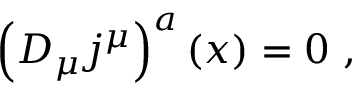Convert formula to latex. <formula><loc_0><loc_0><loc_500><loc_500>\left ( D _ { \mu } j ^ { \mu } \right ) ^ { a } ( x ) = 0 \ ,</formula> 